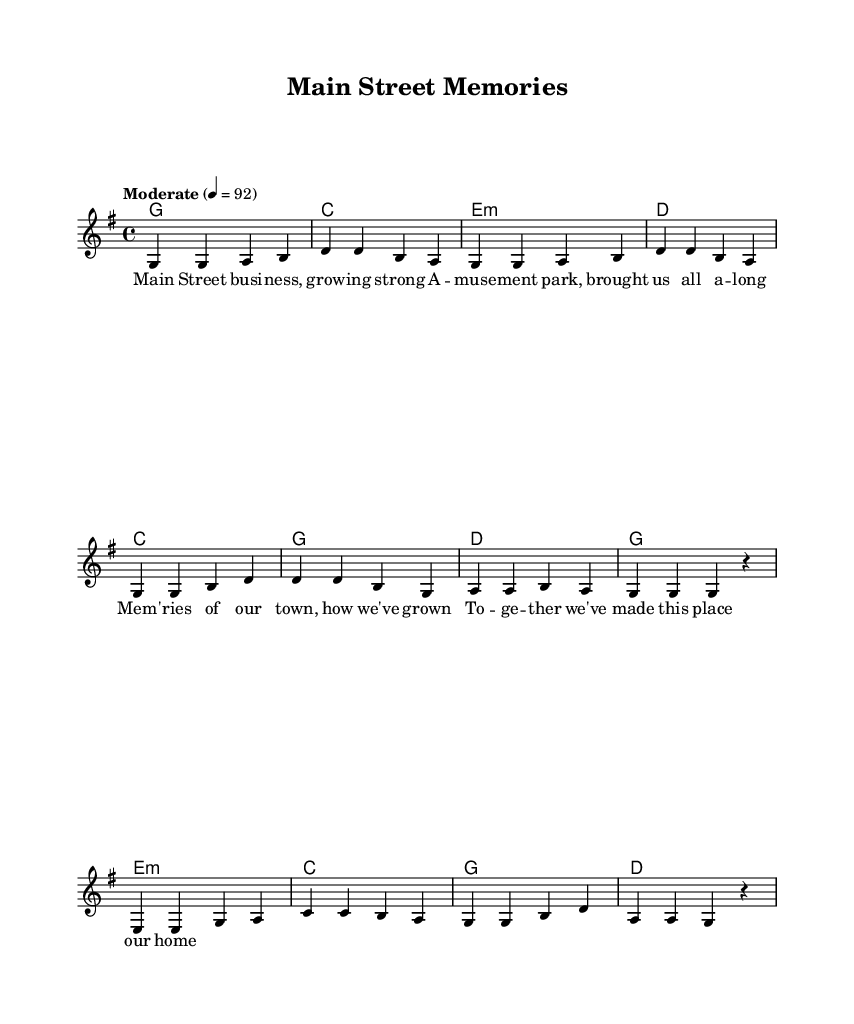What is the key signature of this music? The key signature is indicated at the beginning of the score, showing one sharp (F#) which means it is in the G major scale.
Answer: G major What is the time signature of the piece? The time signature is located near the beginning of the score, presented as 4/4, which means there are four beats in a measure and the quarter note gets one beat.
Answer: 4/4 What is the tempo marking for this piece? The tempo is described in the score, showing a marking of "Moderate" with a tempo of 92 beats per minute, indicating the speed the piece should be played.
Answer: Moderate 92 How many measures are there in the verse? Counting from the beginning of the score, there are a total of 4 measures in the verse section based on the given melody.
Answer: 4 Which section has the lyric "Mem -- 'ries of our town, how we've grown"? By analyzing the lyrics positioned with the melody, this phrase is found under the chorus section of the song.
Answer: Chorus What type of chord is the first chord in the verse? The chord at the start of the verse is a G major chord, indicated in the harmonies section, which has a root note G, and fits the structure of country rock.
Answer: G major Which part of the song contains the bridge? The bridge is located in the score after the verse and chorus, identified by its unique melody and lyrics that differentiate it from the other sections.
Answer: Bridge 